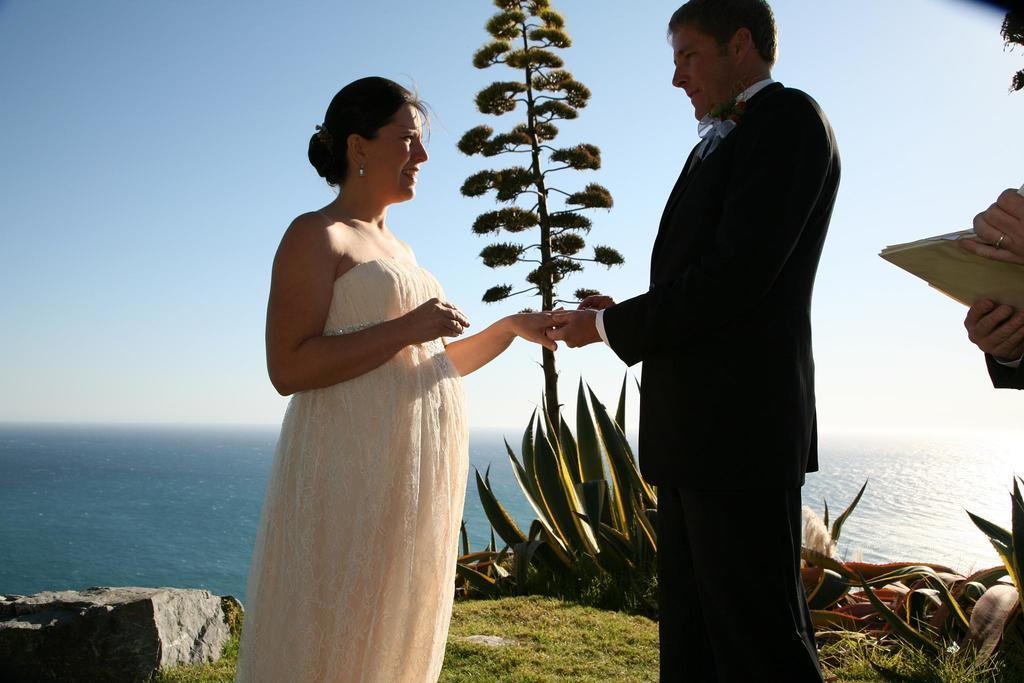How many people are in the image? There is a woman and a man in the image. What are the man and woman doing in the image? The man and woman are standing on the grass, and the man is holding the woman's hand. What type of vegetation can be seen in the image? There are plants, a tree, and grass visible in the image. What natural element is visible in the image? Water is visible in the image. What is visible in the background of the image? The sky is visible in the background of the image. What type of brass instrument is the woman playing in the image? There is no brass instrument present in the image. What level of difficulty is the man attempting in the image? The image does not depict any activity that involves levels of difficulty. 